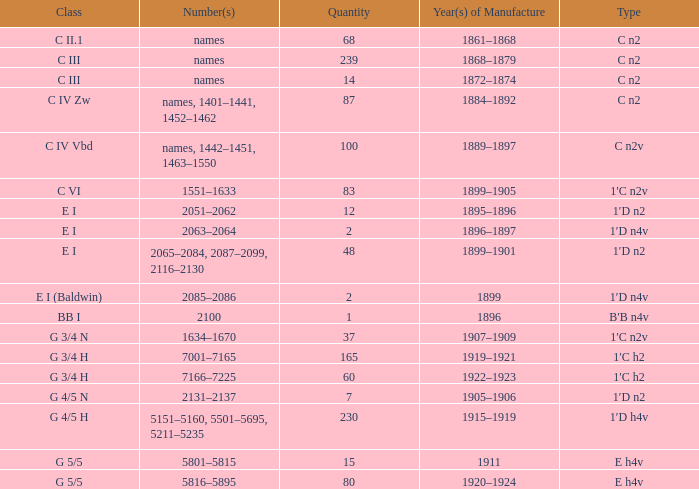Which Class has a Year(s) of Manufacture of 1899? E I (Baldwin). Can you parse all the data within this table? {'header': ['Class', 'Number(s)', 'Quantity', 'Year(s) of Manufacture', 'Type'], 'rows': [['C II.1', 'names', '68', '1861–1868', 'C n2'], ['C III', 'names', '239', '1868–1879', 'C n2'], ['C III', 'names', '14', '1872–1874', 'C n2'], ['C IV Zw', 'names, 1401–1441, 1452–1462', '87', '1884–1892', 'C n2'], ['C IV Vbd', 'names, 1442–1451, 1463–1550', '100', '1889–1897', 'C n2v'], ['C VI', '1551–1633', '83', '1899–1905', '1′C n2v'], ['E I', '2051–2062', '12', '1895–1896', '1′D n2'], ['E I', '2063–2064', '2', '1896–1897', '1′D n4v'], ['E I', '2065–2084, 2087–2099, 2116–2130', '48', '1899–1901', '1′D n2'], ['E I (Baldwin)', '2085–2086', '2', '1899', '1′D n4v'], ['BB I', '2100', '1', '1896', 'B′B n4v'], ['G 3/4 N', '1634–1670', '37', '1907–1909', '1′C n2v'], ['G 3/4 H', '7001–7165', '165', '1919–1921', '1′C h2'], ['G 3/4 H', '7166–7225', '60', '1922–1923', '1′C h2'], ['G 4/5 N', '2131–2137', '7', '1905–1906', '1′D n2'], ['G 4/5 H', '5151–5160, 5501–5695, 5211–5235', '230', '1915–1919', '1′D h4v'], ['G 5/5', '5801–5815', '15', '1911', 'E h4v'], ['G 5/5', '5816–5895', '80', '1920–1924', 'E h4v']]} 